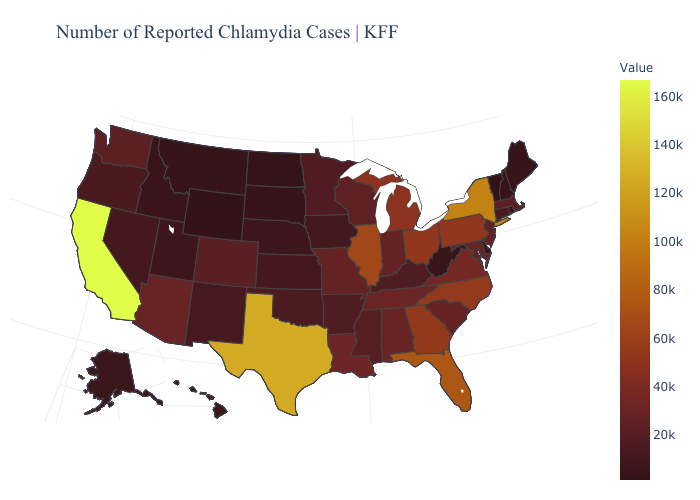Among the states that border Pennsylvania , which have the highest value?
Give a very brief answer. New York. Among the states that border Mississippi , does Tennessee have the highest value?
Short answer required. No. Does Illinois have a lower value than New York?
Short answer required. Yes. Among the states that border Alabama , does Florida have the lowest value?
Concise answer only. No. 